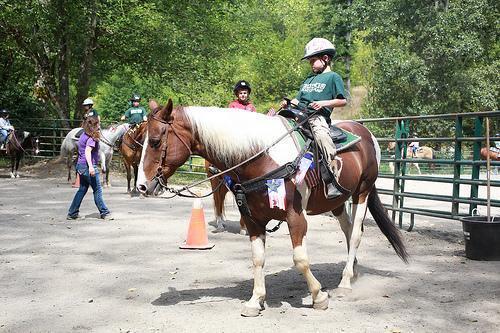How many white legs does the horse have?
Give a very brief answer. 4. 